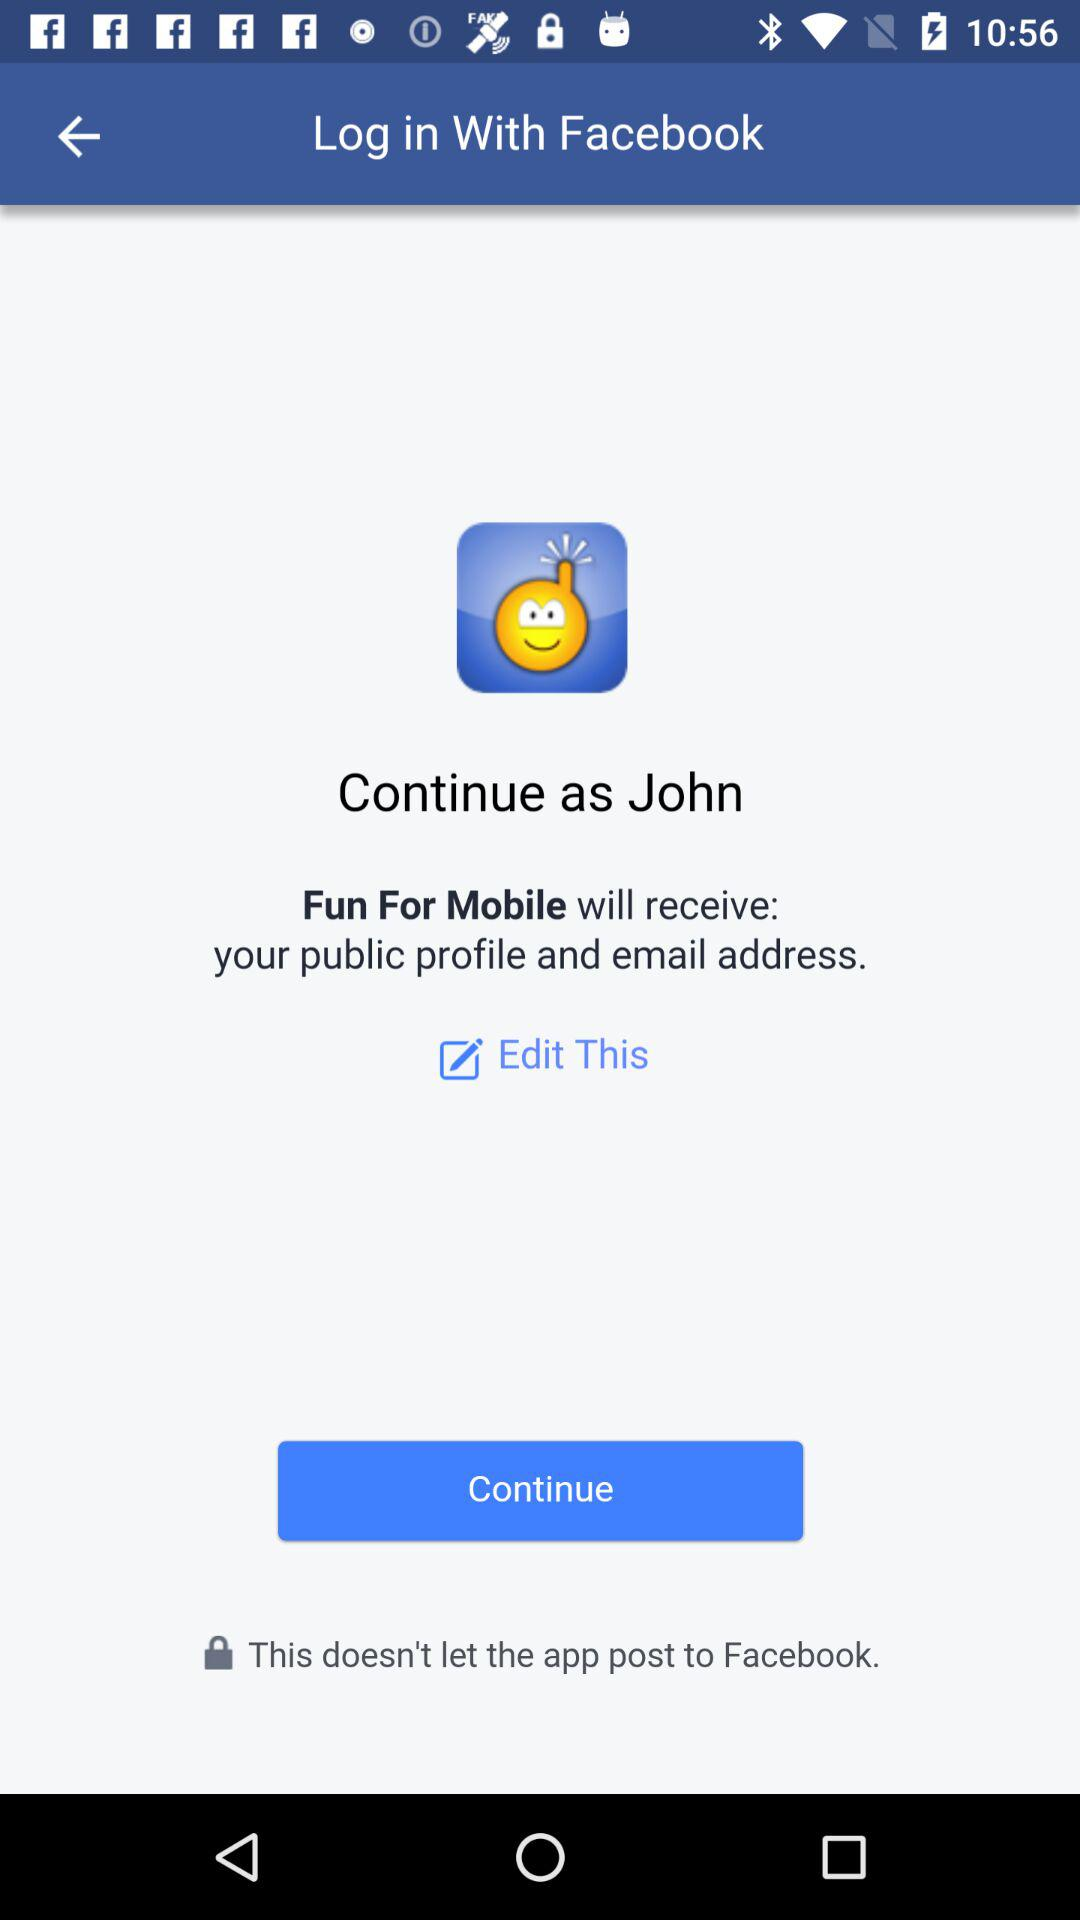What is the user name? The user name is John. 